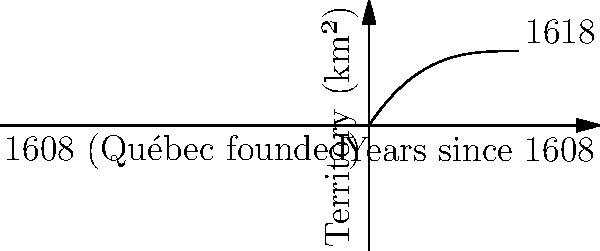As a descendant of the Boucher family, you're researching the territorial expansion of New France. The graph shows the estimated area of New France from 1608 to 1618, where $f(x) = 0.005x^3 - 0.15x^2 + 1.5x$ represents the territory in square kilometers, and $x$ is the number of years since 1608. Calculate the average rate of territorial expansion (in km²/year) over this 10-year period using the concept of average value of a function. To solve this problem, we'll follow these steps:

1) The average value of a function $f(x)$ over an interval $[a,b]$ is given by:

   $$\frac{1}{b-a} \int_{a}^{b} f(x) dx$$

2) In this case, $a=0$, $b=10$, and $f(x) = 0.005x^3 - 0.15x^2 + 1.5x$

3) We need to calculate:

   $$\frac{1}{10-0} \int_{0}^{10} (0.005x^3 - 0.15x^2 + 1.5x) dx$$

4) Integrate the function:

   $$\int (0.005x^3 - 0.15x^2 + 1.5x) dx = 0.00125x^4 - 0.05x^3 + 0.75x^2 + C$$

5) Apply the limits:

   $$[\frac{1}{10}(0.00125x^4 - 0.05x^3 + 0.75x^2)]_{0}^{10}$$

6) Calculate:

   $$\frac{1}{10}[(0.00125(10000) - 0.05(1000) + 0.75(100)) - (0)]$$
   $$= \frac{1}{10}[12.5 - 50 + 75]$$
   $$= \frac{37.5}{10} = 3.75$$

7) Therefore, the average rate of territorial expansion over the 10-year period is 3.75 km²/year.
Answer: 3.75 km²/year 